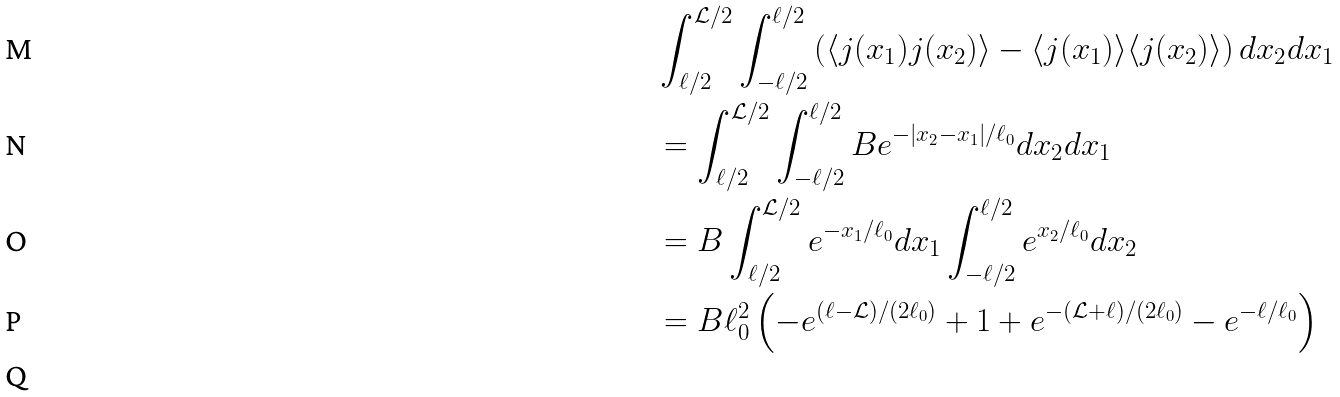<formula> <loc_0><loc_0><loc_500><loc_500>& \int _ { \ell / 2 } ^ { \mathcal { L } / 2 } \int _ { - \ell / 2 } ^ { \ell / 2 } \left ( \langle j ( x _ { 1 } ) j ( x _ { 2 } ) \rangle - \langle j ( x _ { 1 } ) \rangle \langle j ( x _ { 2 } ) \rangle \right ) d x _ { 2 } d x _ { 1 } \\ & = \int _ { \ell / 2 } ^ { \mathcal { L } / 2 } \int _ { - \ell / 2 } ^ { \ell / 2 } B e ^ { - | x _ { 2 } - x _ { 1 } | / { \ell _ { 0 } } } d x _ { 2 } d x _ { 1 } \\ & = B \int _ { \ell / 2 } ^ { \mathcal { L } / 2 } e ^ { - x _ { 1 } / \ell _ { 0 } } d x _ { 1 } \int _ { - \ell / 2 } ^ { \ell / 2 } e ^ { x _ { 2 } / \ell _ { 0 } } d x _ { 2 } \\ & = B \ell _ { 0 } ^ { 2 } \left ( - e ^ { ( \ell - \mathcal { L } ) / ( 2 \ell _ { 0 } ) } + 1 + e ^ { - ( \mathcal { L } + \ell ) / ( 2 \ell _ { 0 } ) } - e ^ { - \ell / \ell _ { 0 } } \right ) \\</formula> 